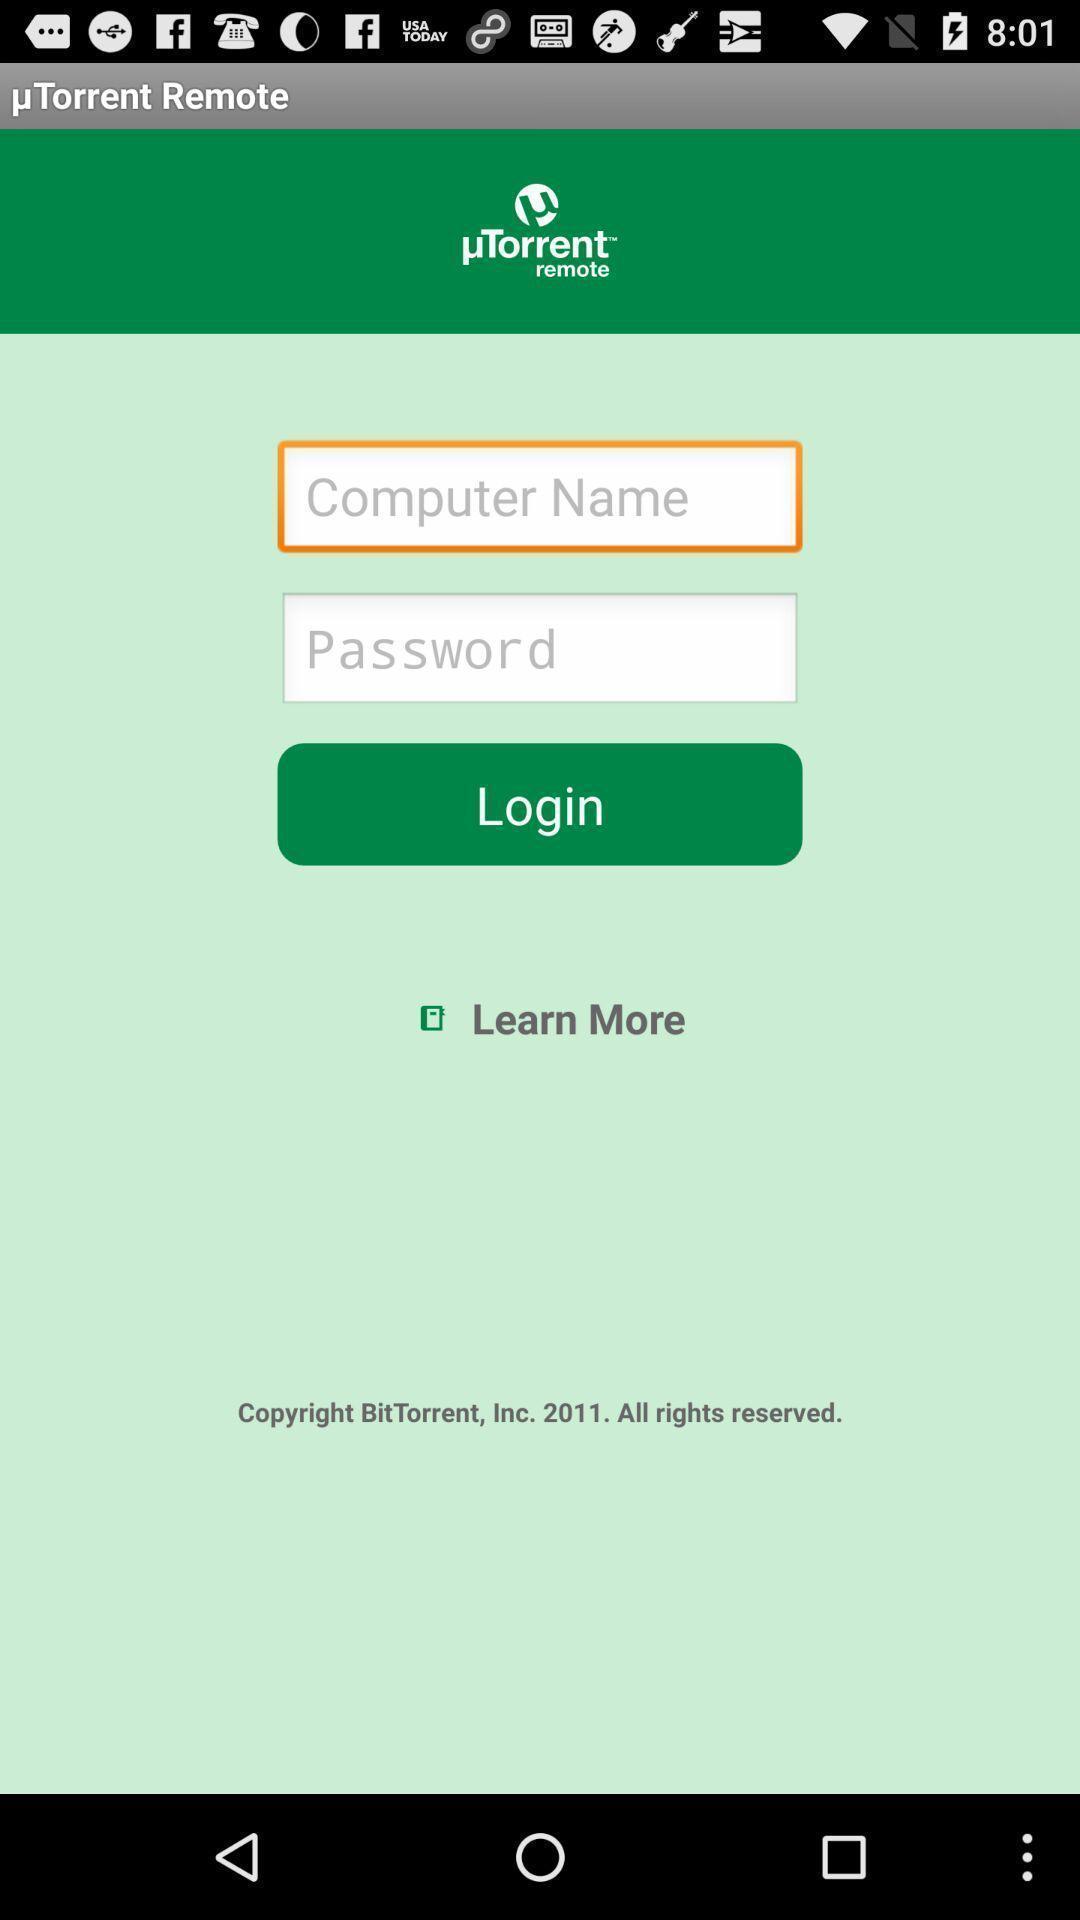Describe the content in this image. Login page of an account. 